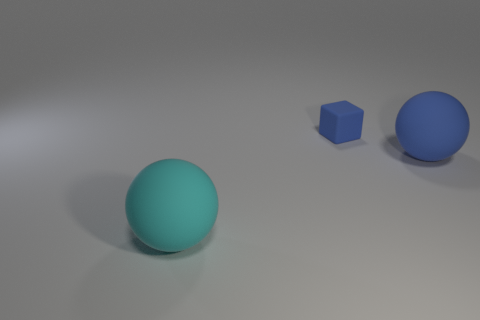Add 3 cyan matte spheres. How many objects exist? 6 Subtract all blocks. How many objects are left? 2 Subtract all large blue balls. Subtract all small blue matte cubes. How many objects are left? 1 Add 1 big cyan matte things. How many big cyan matte things are left? 2 Add 3 large yellow matte balls. How many large yellow matte balls exist? 3 Subtract 1 blue cubes. How many objects are left? 2 